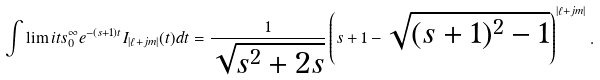<formula> <loc_0><loc_0><loc_500><loc_500>\int \lim i t s _ { 0 } ^ { \infty } e ^ { - ( s + 1 ) t } I _ { | \ell + j m | } ( t ) d t = \frac { 1 } { \sqrt { s ^ { 2 } + 2 s } } \left ( s + 1 - \sqrt { ( s + 1 ) ^ { 2 } - 1 } \right ) ^ { | \ell + j m | } .</formula> 